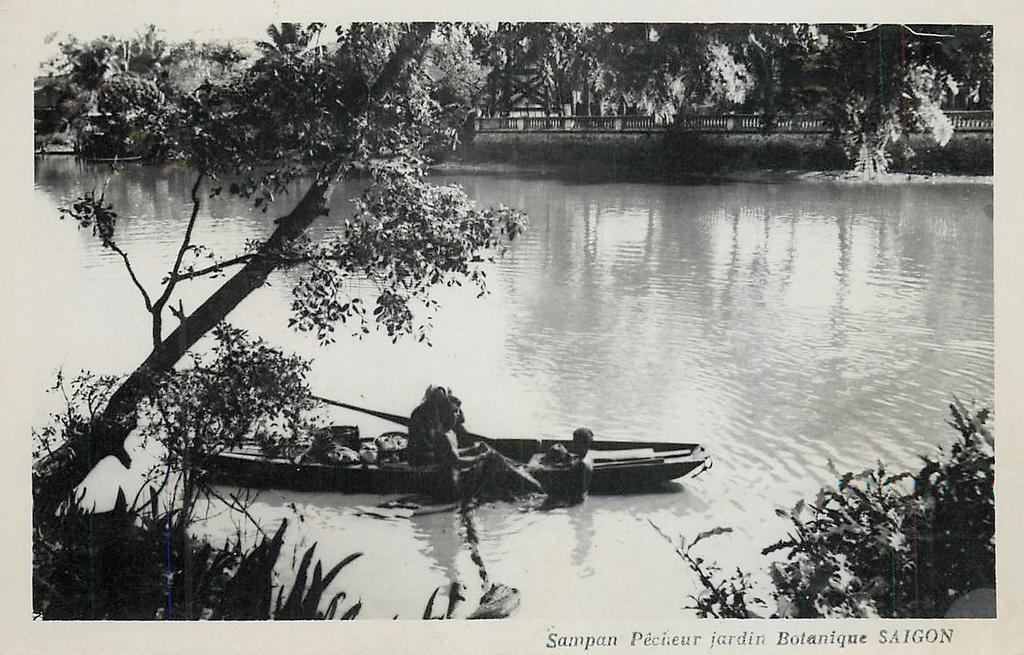How would you summarize this image in a sentence or two? It is the black and white image in which there is a boat in the water. In the boat there are few people sitting in it and rowing with the sticks. At the bottom there are plants. In the background there is a wall and above the wall there is railing. 